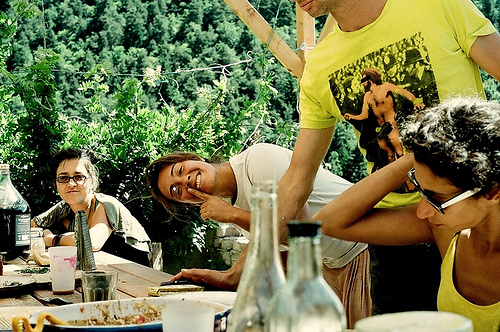<image>
Is the woman behind the man? Yes. From this viewpoint, the woman is positioned behind the man, with the man partially or fully occluding the woman. 